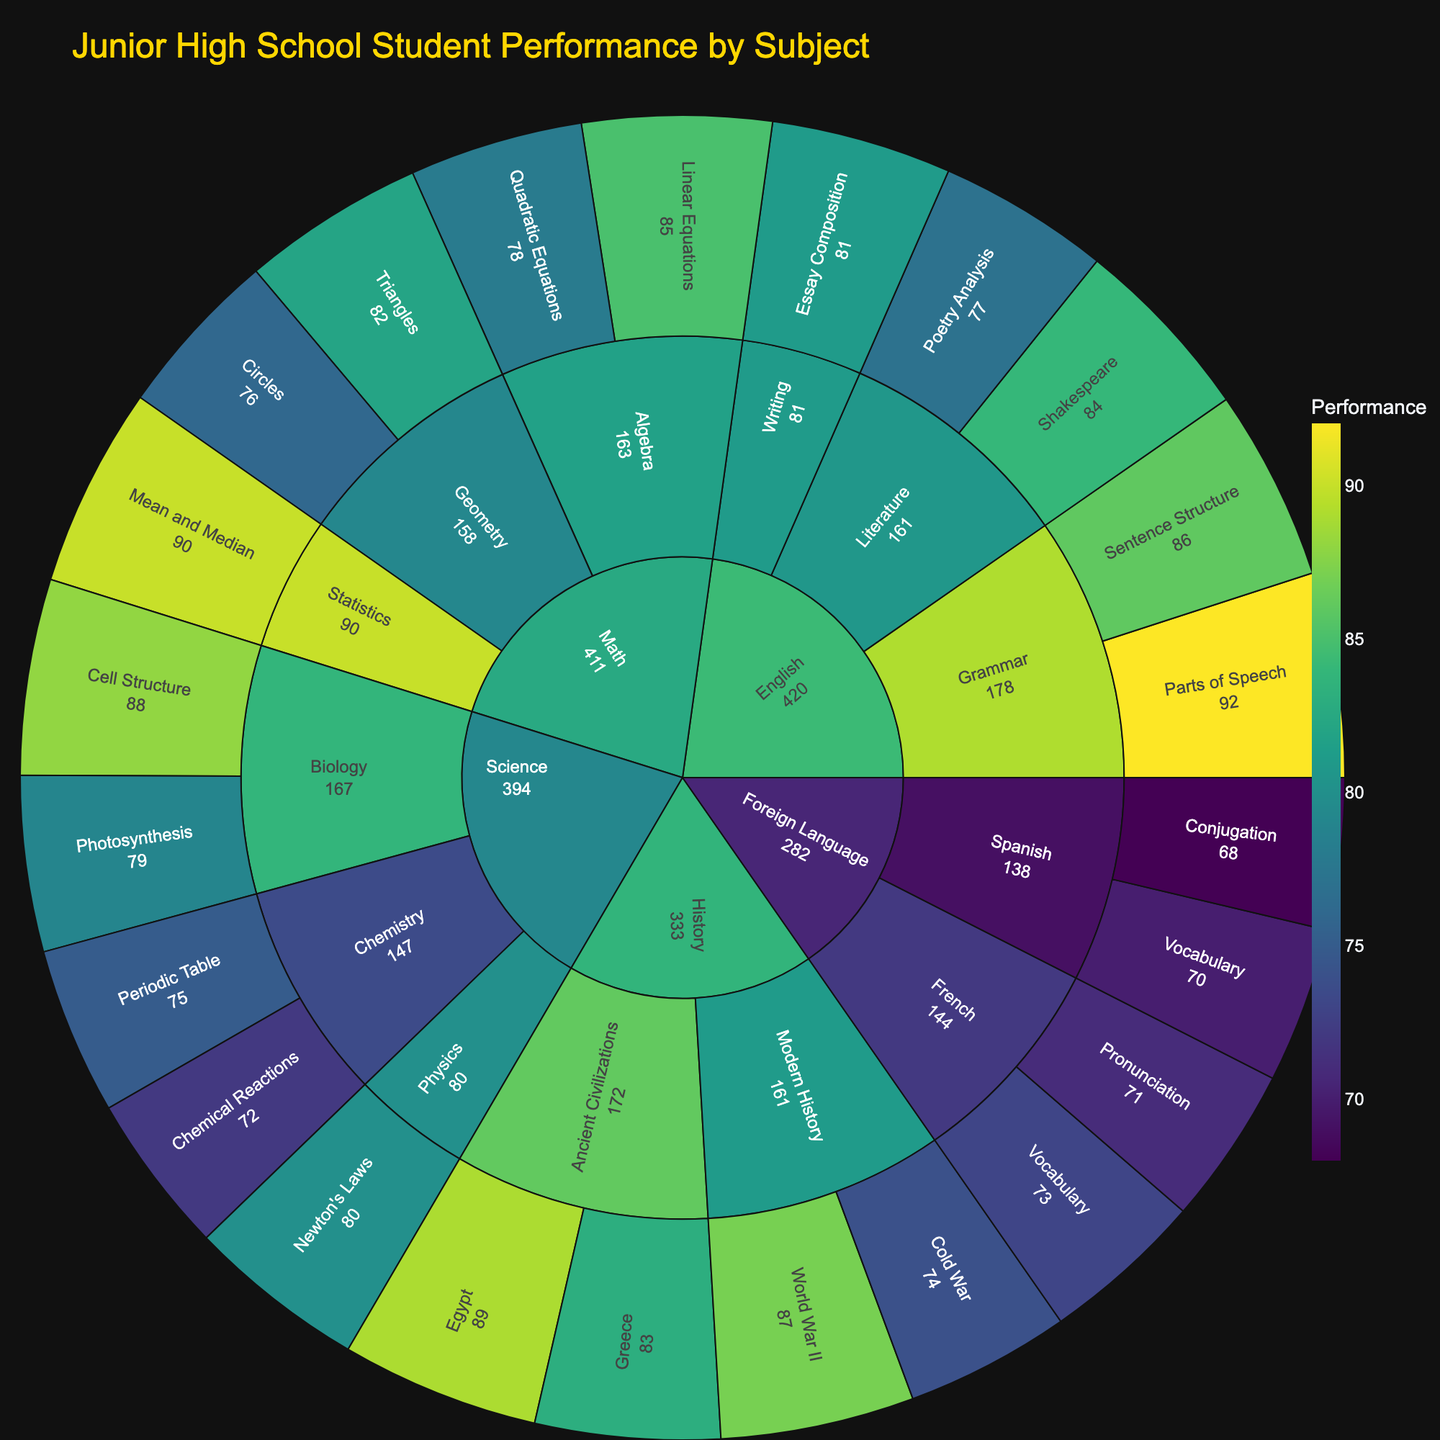what is the title of the figure? The title is usually found at the top of the plot and provides an overview of what the figure represents. In this case, it should indicate that the figure shows student performance data across various subjects.
Answer: Junior High School Student Performance by Subject Which subject has the highest average performance? To find this, look at each subject category, calculate the average performance for each subcategory within it, then compare each subject's average. Math: (85+78+82+76+90)/5 = 82.2, Science: (88+79+75+72+80)/5 = 78.8, English: (84+77+92+86+81)/5 = 84, History: (89+83+87+74)/4 = 83.25, Foreign Language: (70+68+73+71)/4 = 70.5
Answer: English Which topic under Science has the lowest performance? Locate the Science section in the Sunburst plot, then follow its branches to find the lowest performance value among all topics under Science.
Answer: Chemical Reactions Compare the performance in Maths for Triangles and Circles. Which one is higher? Look under the Geometry category within Math and compare the performance scores for Triangles and Circles. Triangles: 82, Circles: 76.
Answer: Triangles What is the combined performance score for all History topics? Sum up the performance scores for all topics listed under History. Egypt: 89, Greece: 83, World War II: 87, Cold War: 74. 89 + 83 + 87 + 74 = 333
Answer: 333 Which category under Math has better average performance, Algebra or Geometry? Calculate the average performance for each category. Algebra: (85+78)/2 = 81.5, Geometry: (82+76)/2 = 79.
Answer: Algebra What is the overall performance score for all English subjects? Sum up the performance scores for all topics listed under English. Shakespeare: 84, Poetry Analysis: 77, Parts of Speech: 92, Sentence Structure: 86, Essay Composition: 81. 84 + 77 + 92 + 86 + 81 = 420
Answer: 420 Which subject has the lowest individual performance score, and what is that score? Find the lowest score among all the individual performance values across all subjects. The lowest performance score in the dataset is 68, under Spanish.
Answer: Spanish, 68 How many topics are there under the Foreign Language subject? Count the number of individual branches/topics listed under Foreign Language in the sunburst plot. There are two main branches, Spanish and French, each with two topics.
Answer: 4 